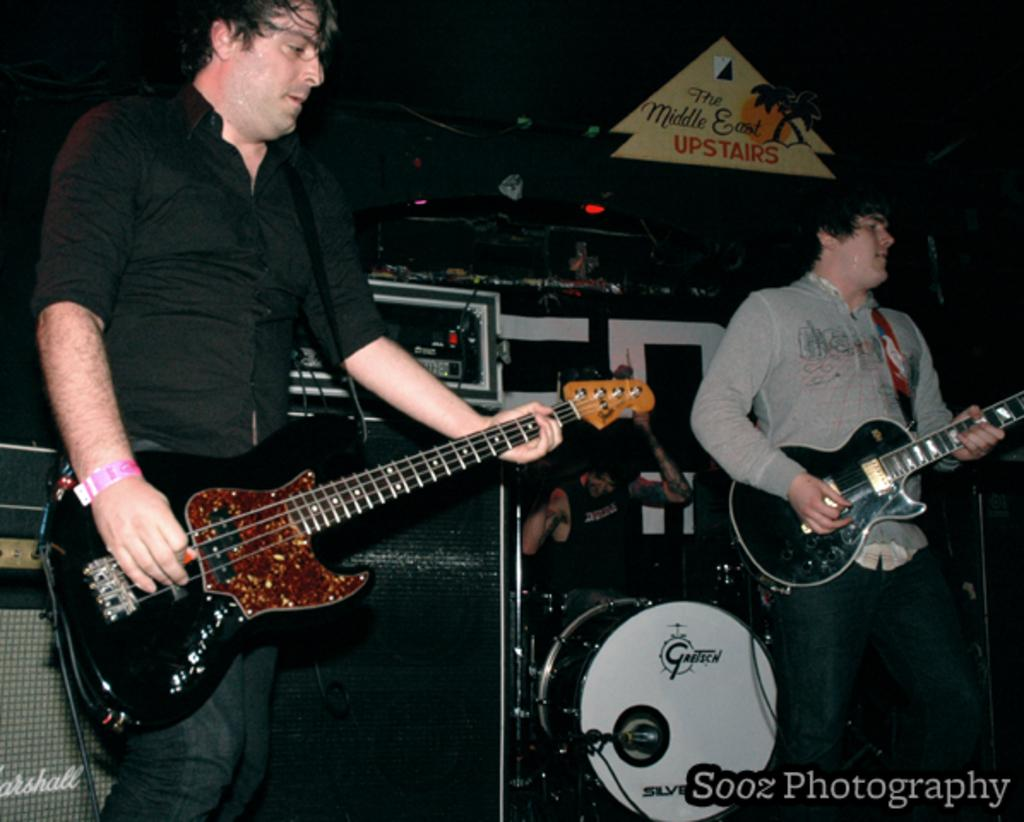Where was the image taken? The image is taken on a stage. How many people are in the image? There are two persons in the image. What are the two persons holding? The two persons are holding guitars. What are the two persons doing in the image? The two persons are singing a song. What can be seen in the background of the image? There are music instruments in the background, and the background is black in color. What month is it in the image? The image does not provide any information about the month, so it cannot be determined. Can you see a yoke in the image? There is no yoke present in the image. 